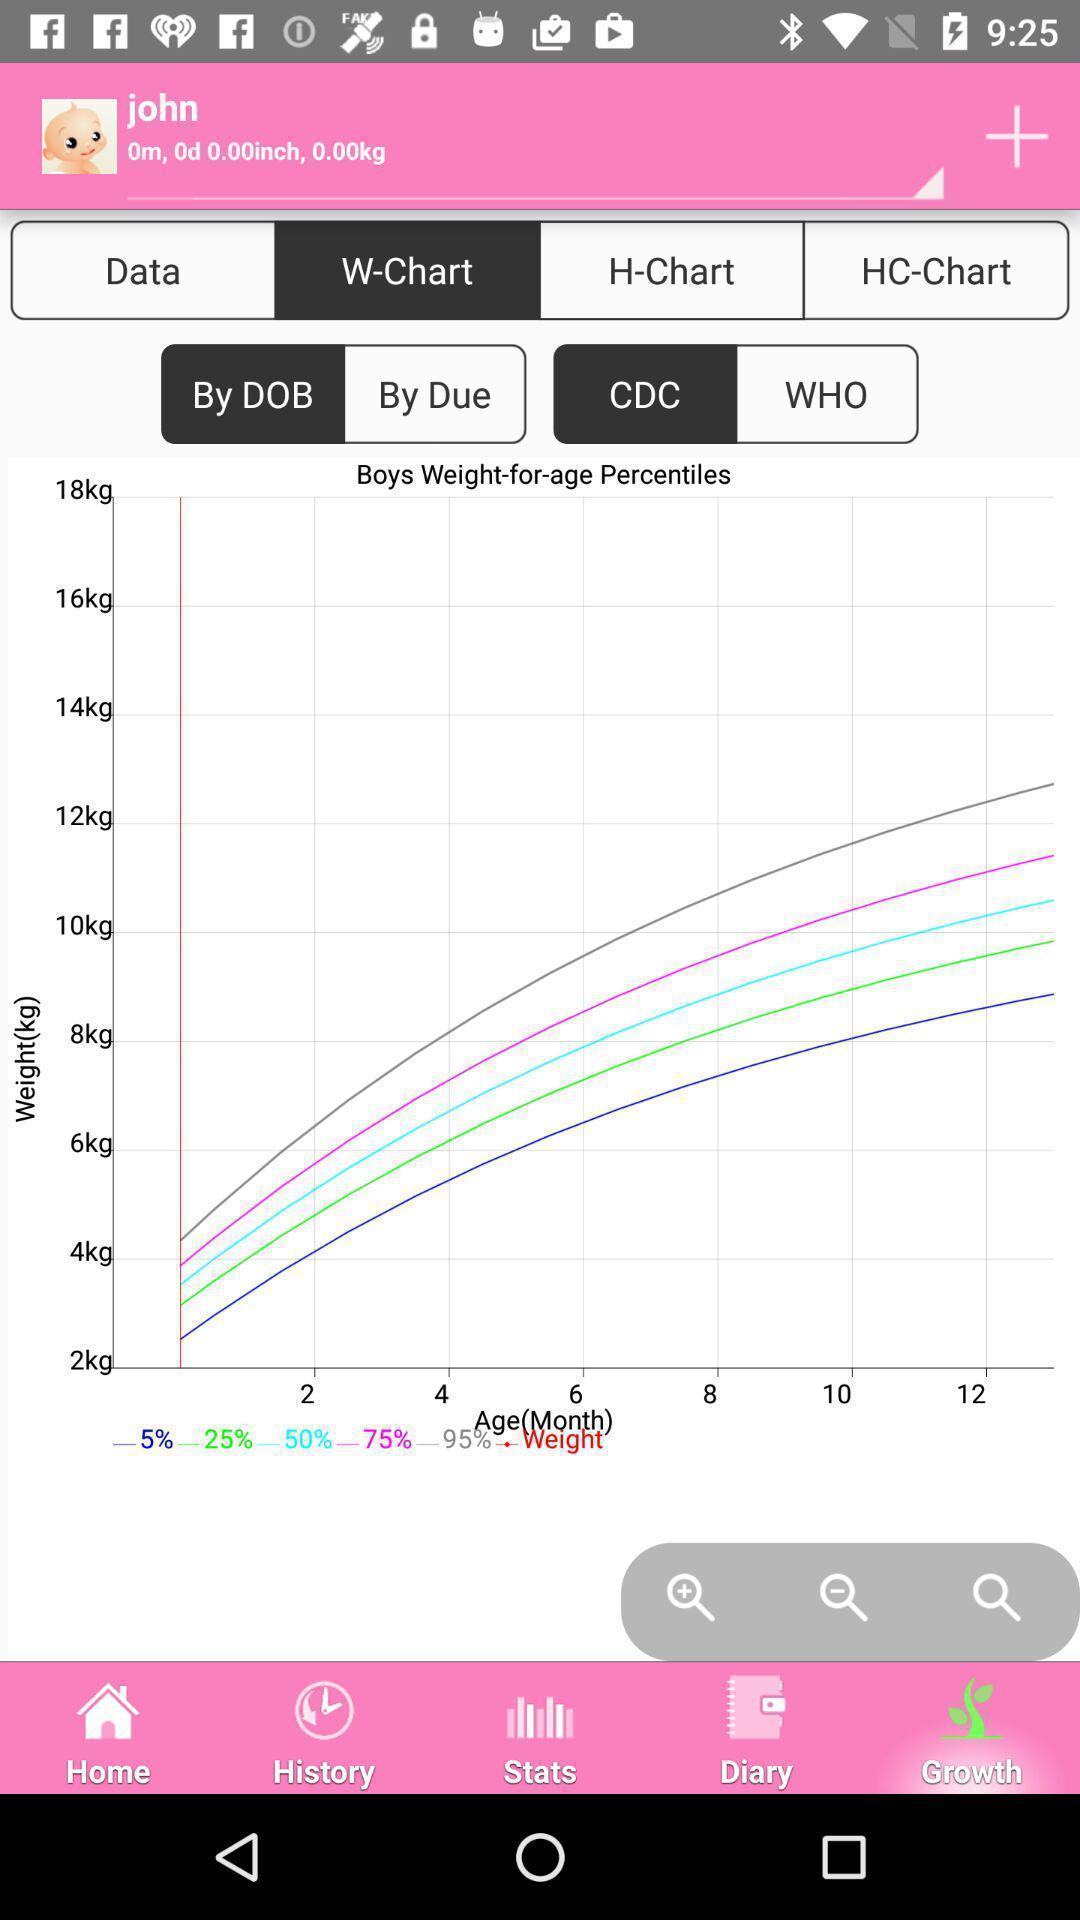What is the overall content of this screenshot? Screen shows graph details in a health app. 